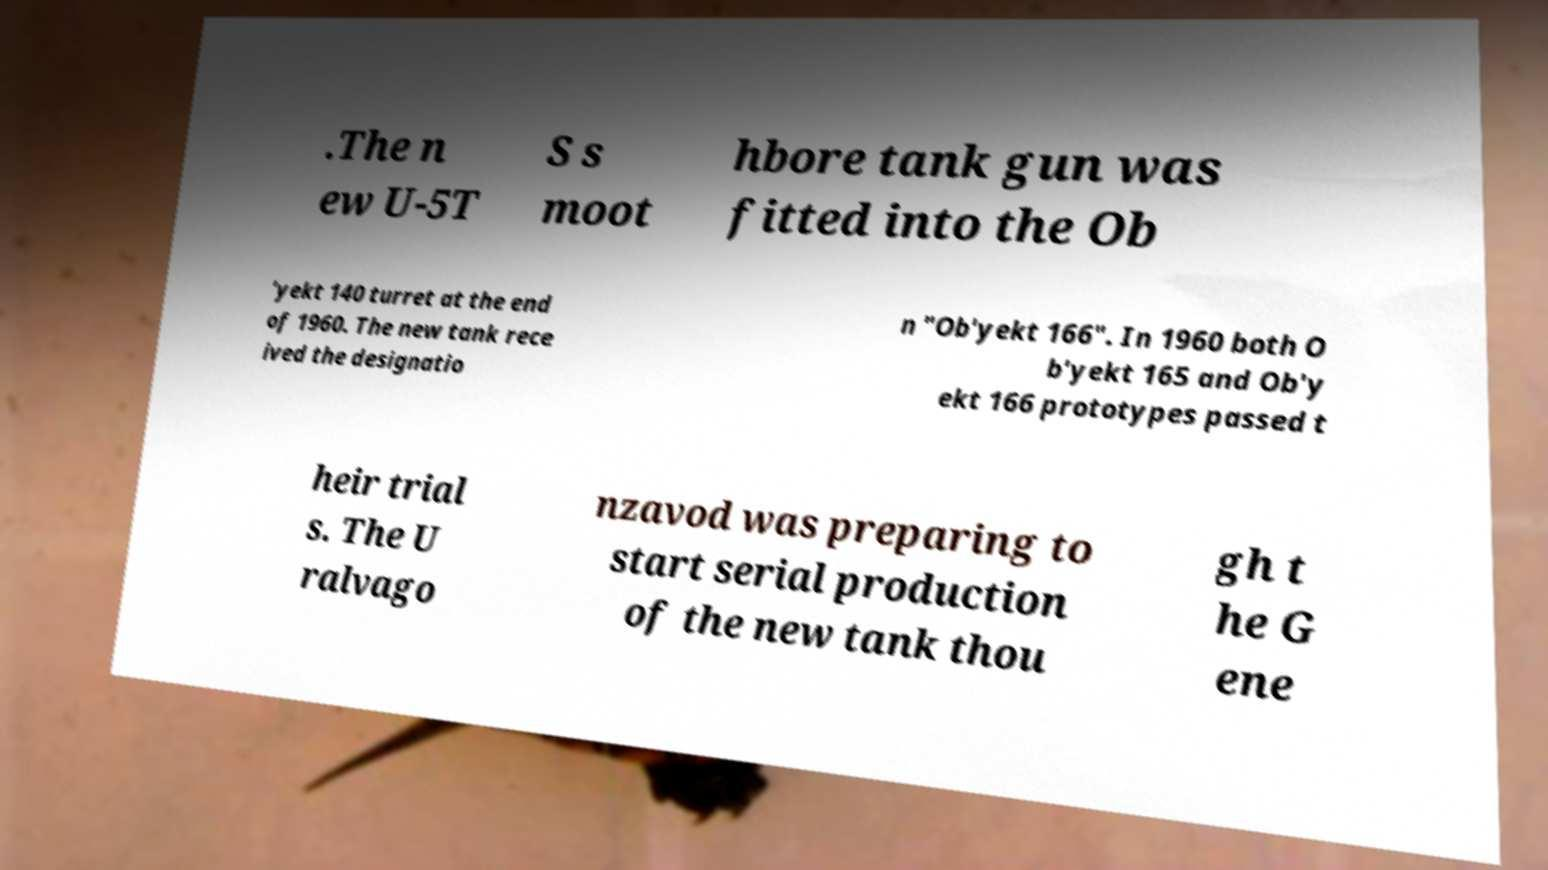What messages or text are displayed in this image? I need them in a readable, typed format. .The n ew U-5T S s moot hbore tank gun was fitted into the Ob 'yekt 140 turret at the end of 1960. The new tank rece ived the designatio n "Ob'yekt 166". In 1960 both O b'yekt 165 and Ob'y ekt 166 prototypes passed t heir trial s. The U ralvago nzavod was preparing to start serial production of the new tank thou gh t he G ene 